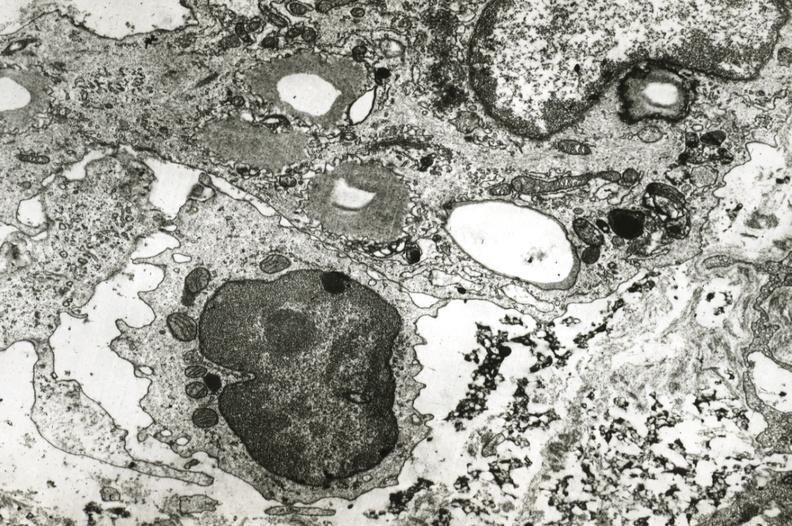s aorta present?
Answer the question using a single word or phrase. No 